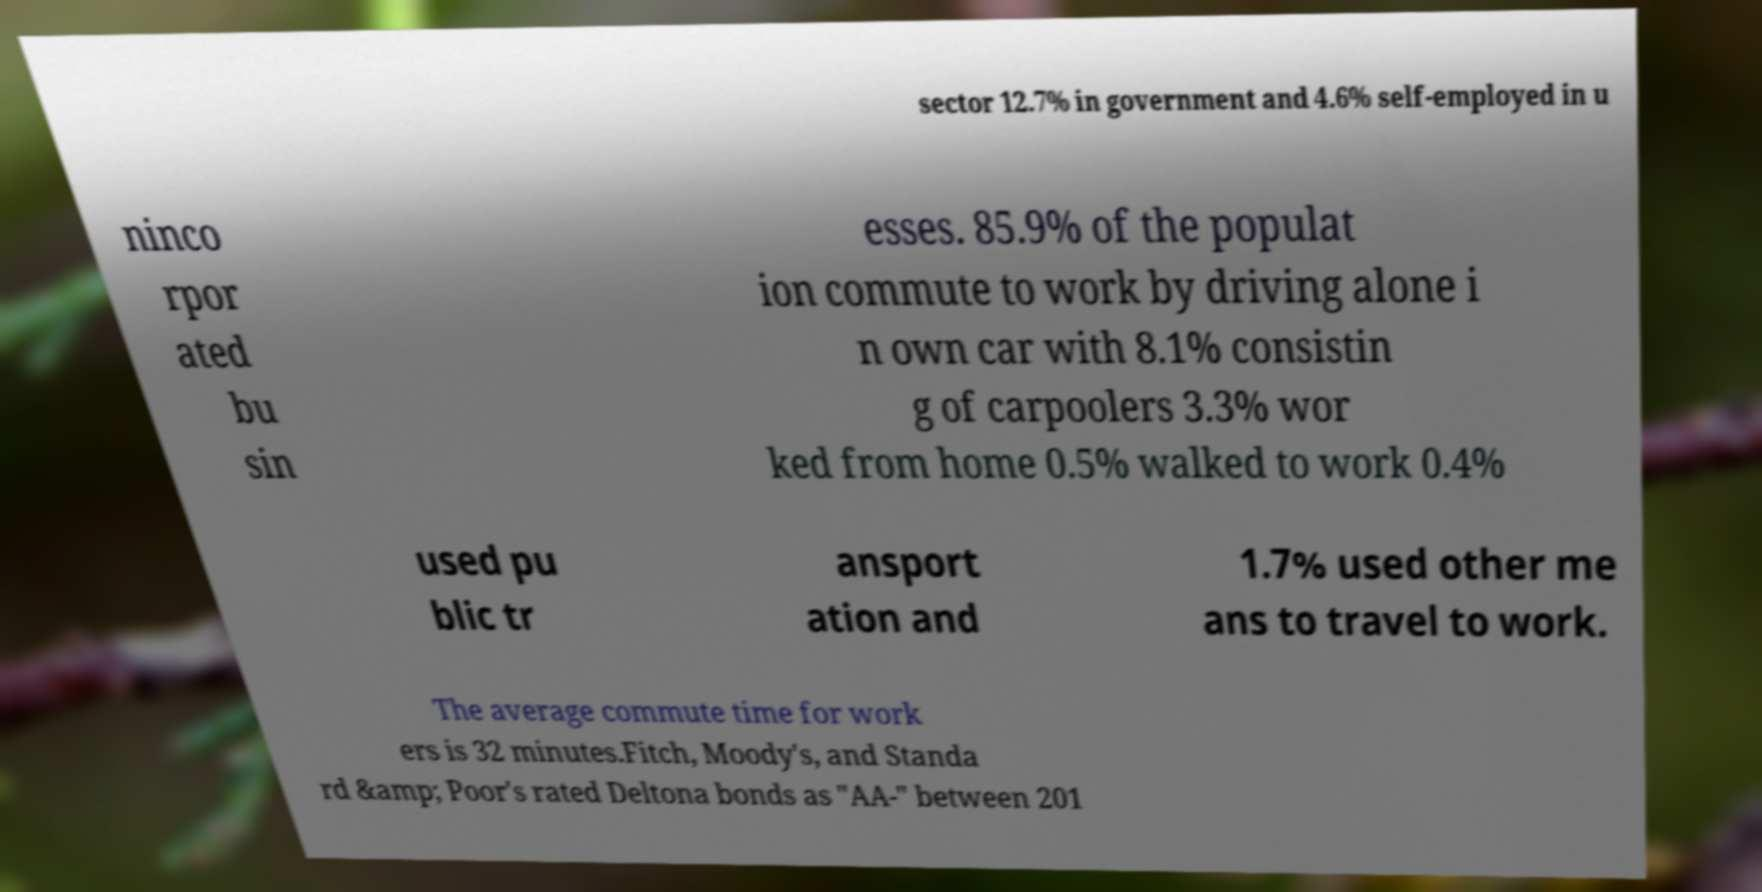Can you read and provide the text displayed in the image?This photo seems to have some interesting text. Can you extract and type it out for me? sector 12.7% in government and 4.6% self-employed in u ninco rpor ated bu sin esses. 85.9% of the populat ion commute to work by driving alone i n own car with 8.1% consistin g of carpoolers 3.3% wor ked from home 0.5% walked to work 0.4% used pu blic tr ansport ation and 1.7% used other me ans to travel to work. The average commute time for work ers is 32 minutes.Fitch, Moody's, and Standa rd &amp; Poor's rated Deltona bonds as "AA-" between 201 